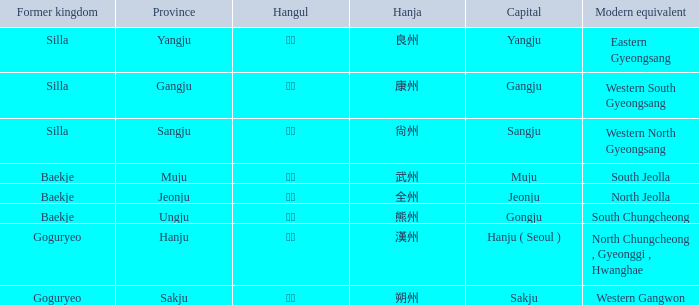What is the contemporary counterpart of the ancient kingdom "silla" with the hanja 尙州? 1.0. Write the full table. {'header': ['Former kingdom', 'Province', 'Hangul', 'Hanja', 'Capital', 'Modern equivalent'], 'rows': [['Silla', 'Yangju', '양주', '良州', 'Yangju', 'Eastern Gyeongsang'], ['Silla', 'Gangju', '강주', '康州', 'Gangju', 'Western South Gyeongsang'], ['Silla', 'Sangju', '상주', '尙州', 'Sangju', 'Western North Gyeongsang'], ['Baekje', 'Muju', '무주', '武州', 'Muju', 'South Jeolla'], ['Baekje', 'Jeonju', '전주', '全州', 'Jeonju', 'North Jeolla'], ['Baekje', 'Ungju', '웅주', '熊州', 'Gongju', 'South Chungcheong'], ['Goguryeo', 'Hanju', '한주', '漢州', 'Hanju ( Seoul )', 'North Chungcheong , Gyeonggi , Hwanghae'], ['Goguryeo', 'Sakju', '삭주', '朔州', 'Sakju', 'Western Gangwon']]} 